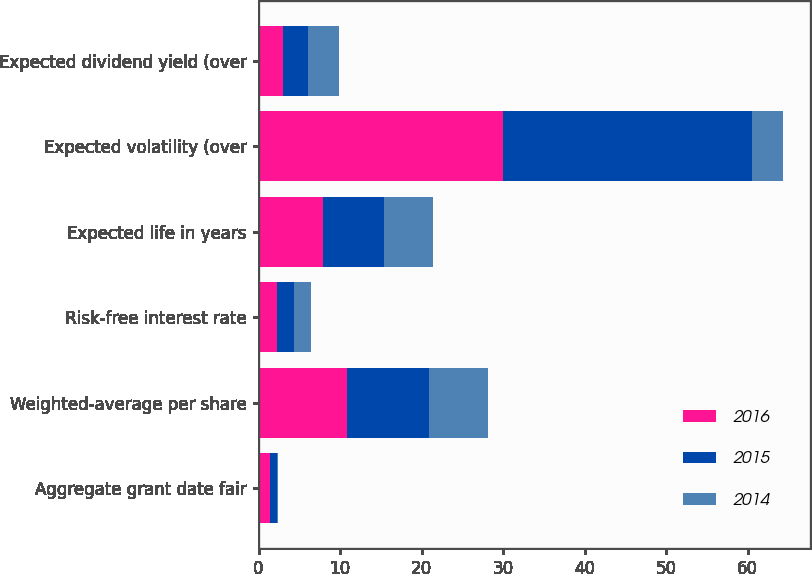Convert chart. <chart><loc_0><loc_0><loc_500><loc_500><stacked_bar_chart><ecel><fcel>Aggregate grant date fair<fcel>Weighted-average per share<fcel>Risk-free interest rate<fcel>Expected life in years<fcel>Expected volatility (over<fcel>Expected dividend yield (over<nl><fcel>2016<fcel>1.4<fcel>10.79<fcel>2.2<fcel>7.9<fcel>30<fcel>3<nl><fcel>2015<fcel>0.9<fcel>10.06<fcel>2.1<fcel>7.5<fcel>30.5<fcel>3<nl><fcel>2014<fcel>0.1<fcel>7.3<fcel>2.1<fcel>6<fcel>3.9<fcel>3.9<nl></chart> 